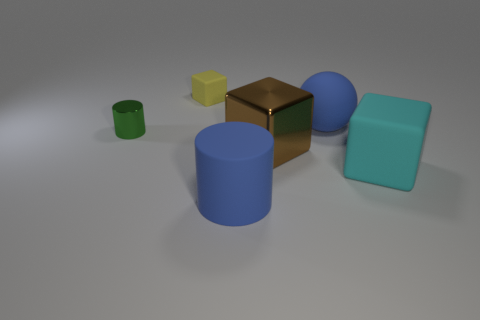Subtract all yellow blocks. How many blocks are left? 2 Add 2 cylinders. How many objects exist? 8 Subtract all spheres. How many objects are left? 5 Subtract all blue cylinders. How many cylinders are left? 1 Subtract 1 cylinders. How many cylinders are left? 1 Subtract all large red rubber cubes. Subtract all large cubes. How many objects are left? 4 Add 4 big blue matte cylinders. How many big blue matte cylinders are left? 5 Add 5 big brown metal things. How many big brown metal things exist? 6 Subtract 0 purple spheres. How many objects are left? 6 Subtract all gray cylinders. Subtract all green balls. How many cylinders are left? 2 